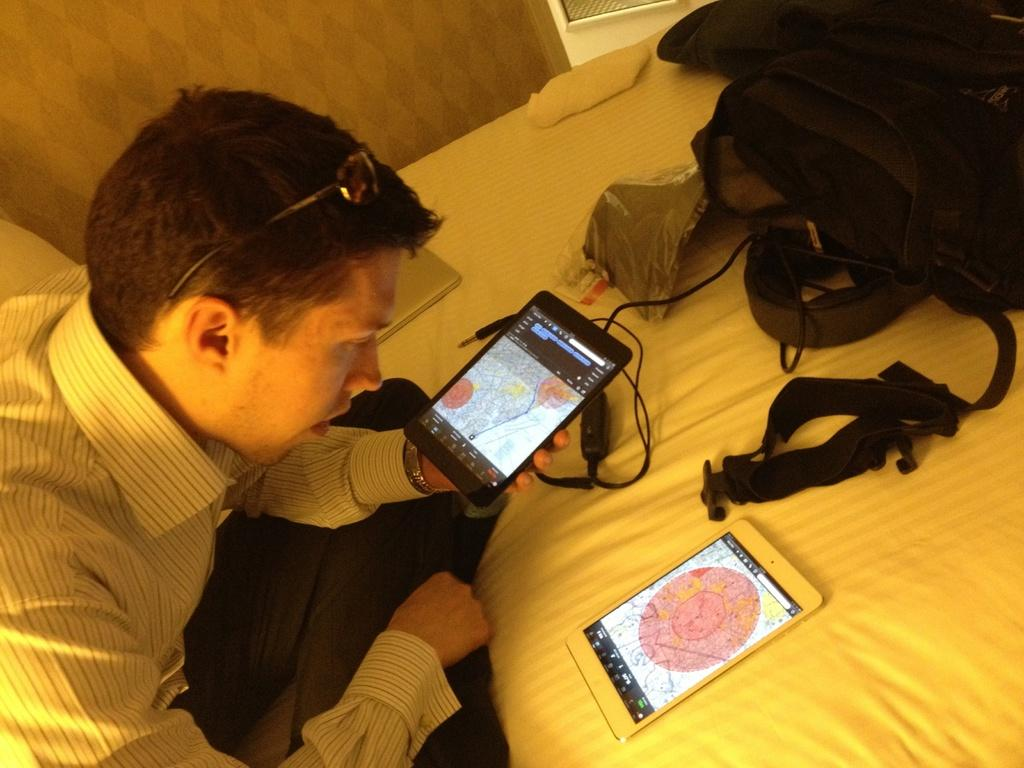What is the man in the image doing? The man is sitting on the bed. What object is the man holding in his hands? The man is holding a mobile phone in his hands. What electronic device can be seen in the image besides the mobile phone? There is a laptop in the image. What items are placed on the bed? Bags are present in the image, and they are placed on the bed. What type of structure can be seen supporting the laptop in the image? There is no visible structure supporting the laptop in the image; it appears to be resting on a surface. 